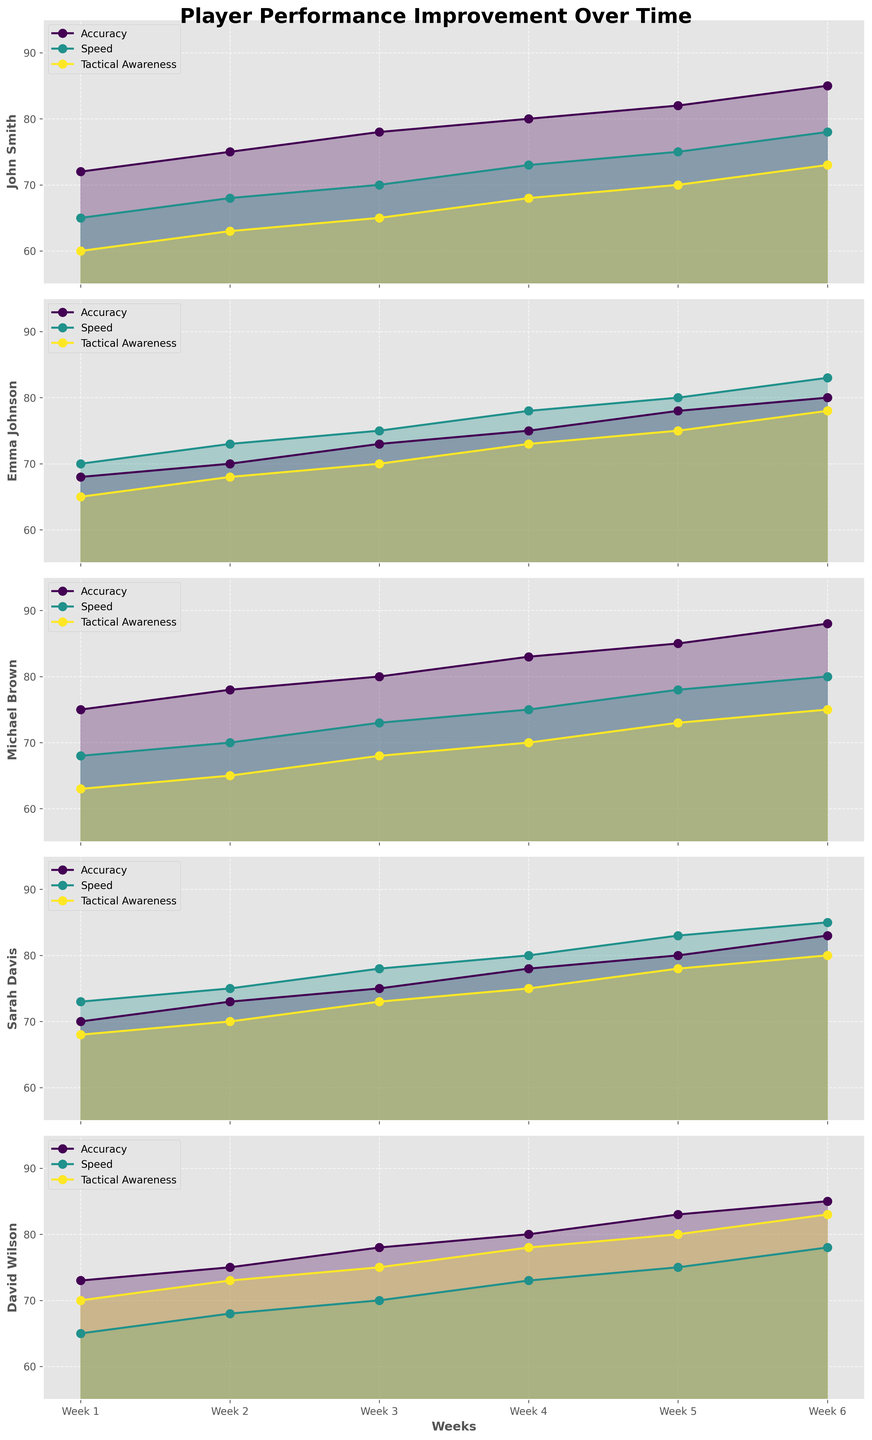What's the title of the figure? The title of the figure is shown at the top and reads "Player Performance Improvement Over Time".
Answer: Player Performance Improvement Over Time Which player showed the greatest improvement in Accuracy from Week 1 to Week 6? You can identify the improvement by looking at the start and end points for Accuracy for each player. Michael Brown's Accuracy rises from 75 in Week 1 to 88 in Week 6.
Answer: Michael Brown What are the metrics displayed in the figure for each player? The legend in each subplot shows the metrics being tracked. The metrics are Accuracy, Speed, and Tactical Awareness.
Answer: Accuracy, Speed, and Tactical Awareness How does Sarah Davis' Speed in Week 3 compare to Emma Johnson's Speed in Week 3? For this, look at the Speed lines in both Sarah Davis's and Emma Johnson's plots for Week 3. Sarah Davis has a Speed of 78, while Emma Johnson has a Speed of 75.
Answer: Sarah Davis What is the average Tactical Awareness score for David Wilson over the six weeks? First, extract David Wilson's Tactical Awareness scores: 70, 73, 75, 78, 80, 83. Add these scores up to get 459. Then divide by 6 to get the average.
Answer: 76.5 Which player had the most consistent improvement across all metrics? Look for the player whose lines for Accuracy, Speed, and Tactical Awareness steadily increase without significant dips. All metrics for John Smith show consistent improvement.
Answer: John Smith Did any player's metric decrease at any point over the six weeks? Check the trends for each metric across all players and weeks. No player's metrics show a decrease; all values either stay the same or increase.
Answer: No Which skill metric shows the highest value recorded for any player in Week 6 and who achieved it? Identify the highest value in Week 6 across all metrics and players. The highest value in Week 6 is Michael Brown's Accuracy, which is 88.
Answer: Accuracy, Michael Brown For Emma Johnson, what is the difference between her Tactical Awareness in Week 6 and Week 1? Emma Johnson's Tactical Awareness starts at 65 in Week 1 and reaches 78 in Week 6. The difference is 78 - 65.
Answer: 13 Compare the initial (Week 1) and final (Week 6) Speed values for John Smith and David Wilson. What can you conclude? John Smith's Speed increases from 65 to 78, while David Wilson's Speed also increases from 65 to 78 over the same period. Both players have identical improvements in Speed.
Answer: Both had the same improvement, 13 points 